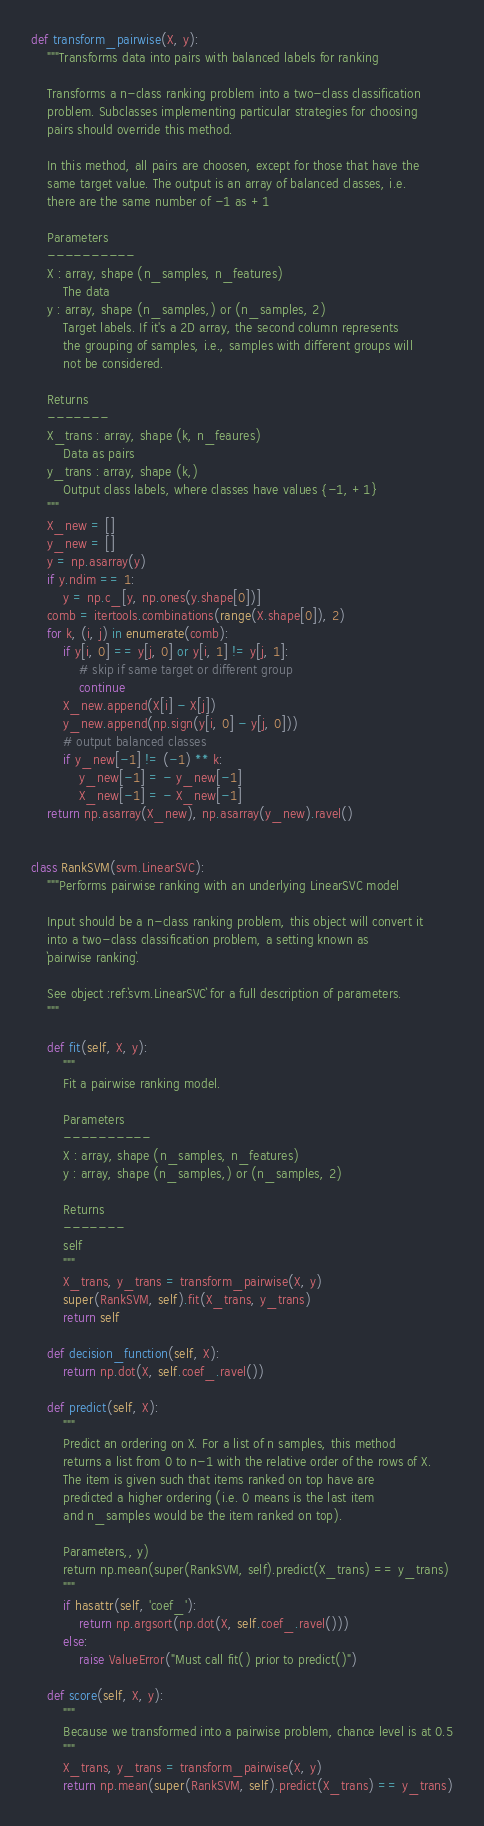Convert code to text. <code><loc_0><loc_0><loc_500><loc_500><_Python_>

def transform_pairwise(X, y):
    """Transforms data into pairs with balanced labels for ranking

    Transforms a n-class ranking problem into a two-class classification
    problem. Subclasses implementing particular strategies for choosing
    pairs should override this method.

    In this method, all pairs are choosen, except for those that have the
    same target value. The output is an array of balanced classes, i.e.
    there are the same number of -1 as +1

    Parameters
    ----------
    X : array, shape (n_samples, n_features)
        The data
    y : array, shape (n_samples,) or (n_samples, 2)
        Target labels. If it's a 2D array, the second column represents
        the grouping of samples, i.e., samples with different groups will
        not be considered.

    Returns
    -------
    X_trans : array, shape (k, n_feaures)
        Data as pairs
    y_trans : array, shape (k,)
        Output class labels, where classes have values {-1, +1}
    """
    X_new = []
    y_new = []
    y = np.asarray(y)
    if y.ndim == 1:
        y = np.c_[y, np.ones(y.shape[0])]
    comb = itertools.combinations(range(X.shape[0]), 2)
    for k, (i, j) in enumerate(comb):
        if y[i, 0] == y[j, 0] or y[i, 1] != y[j, 1]:
            # skip if same target or different group
            continue
        X_new.append(X[i] - X[j])
        y_new.append(np.sign(y[i, 0] - y[j, 0]))
        # output balanced classes
        if y_new[-1] != (-1) ** k:
            y_new[-1] = - y_new[-1]
            X_new[-1] = - X_new[-1]
    return np.asarray(X_new), np.asarray(y_new).ravel()


class RankSVM(svm.LinearSVC):
    """Performs pairwise ranking with an underlying LinearSVC model

    Input should be a n-class ranking problem, this object will convert it
    into a two-class classification problem, a setting known as
    `pairwise ranking`.

    See object :ref:`svm.LinearSVC` for a full description of parameters.
    """

    def fit(self, X, y):
        """
        Fit a pairwise ranking model.

        Parameters
        ----------
        X : array, shape (n_samples, n_features)
        y : array, shape (n_samples,) or (n_samples, 2)

        Returns
        -------
        self
        """
        X_trans, y_trans = transform_pairwise(X, y)
        super(RankSVM, self).fit(X_trans, y_trans)
        return self

    def decision_function(self, X):
        return np.dot(X, self.coef_.ravel())

    def predict(self, X):
        """
        Predict an ordering on X. For a list of n samples, this method
        returns a list from 0 to n-1 with the relative order of the rows of X.
        The item is given such that items ranked on top have are
        predicted a higher ordering (i.e. 0 means is the last item
        and n_samples would be the item ranked on top).

        Parameters,, y)
        return np.mean(super(RankSVM, self).predict(X_trans) == y_trans)
        """
        if hasattr(self, 'coef_'):
            return np.argsort(np.dot(X, self.coef_.ravel()))
        else:
            raise ValueError("Must call fit() prior to predict()")

    def score(self, X, y):
        """
        Because we transformed into a pairwise problem, chance level is at 0.5
        """
        X_trans, y_trans = transform_pairwise(X, y)
        return np.mean(super(RankSVM, self).predict(X_trans) == y_trans)</code> 